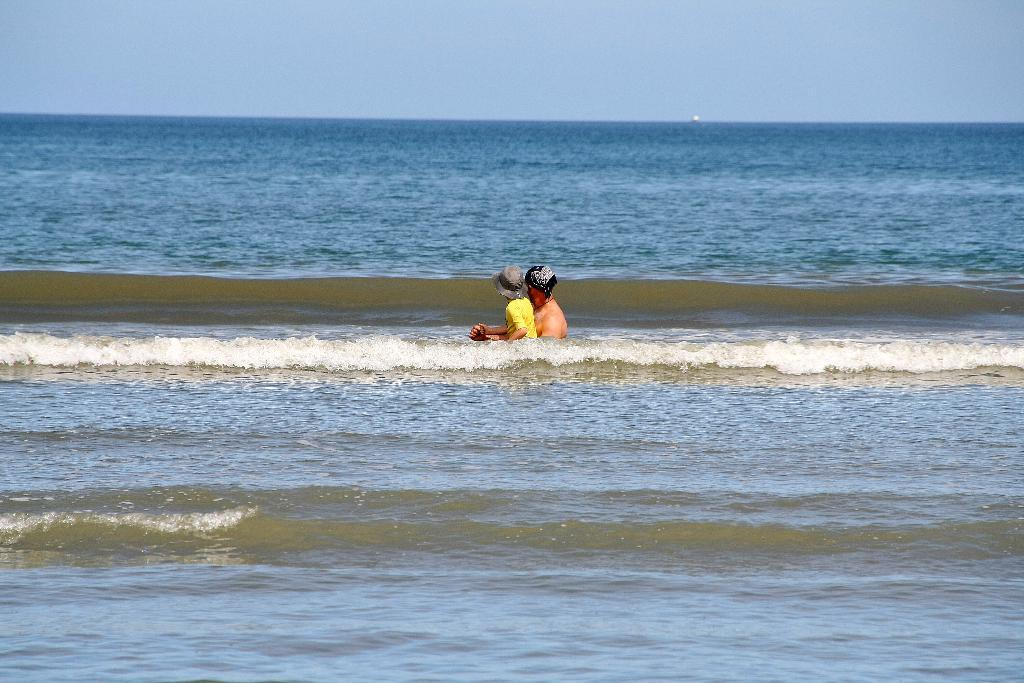How many people are in the water in the image? There are two persons in the water in the image. What are the persons wearing on their heads? Both persons are wearing caps. What can be seen in the background of the image? There is water and the sky visible in the background. What type of soda is being poured into the water by the persons in the image? There is no soda present in the image; it features two persons in the water wearing caps. Can you describe the mist in the image? There is no mist present in the image; it features two persons in the water wearing caps, with water and the sky visible in the background. 